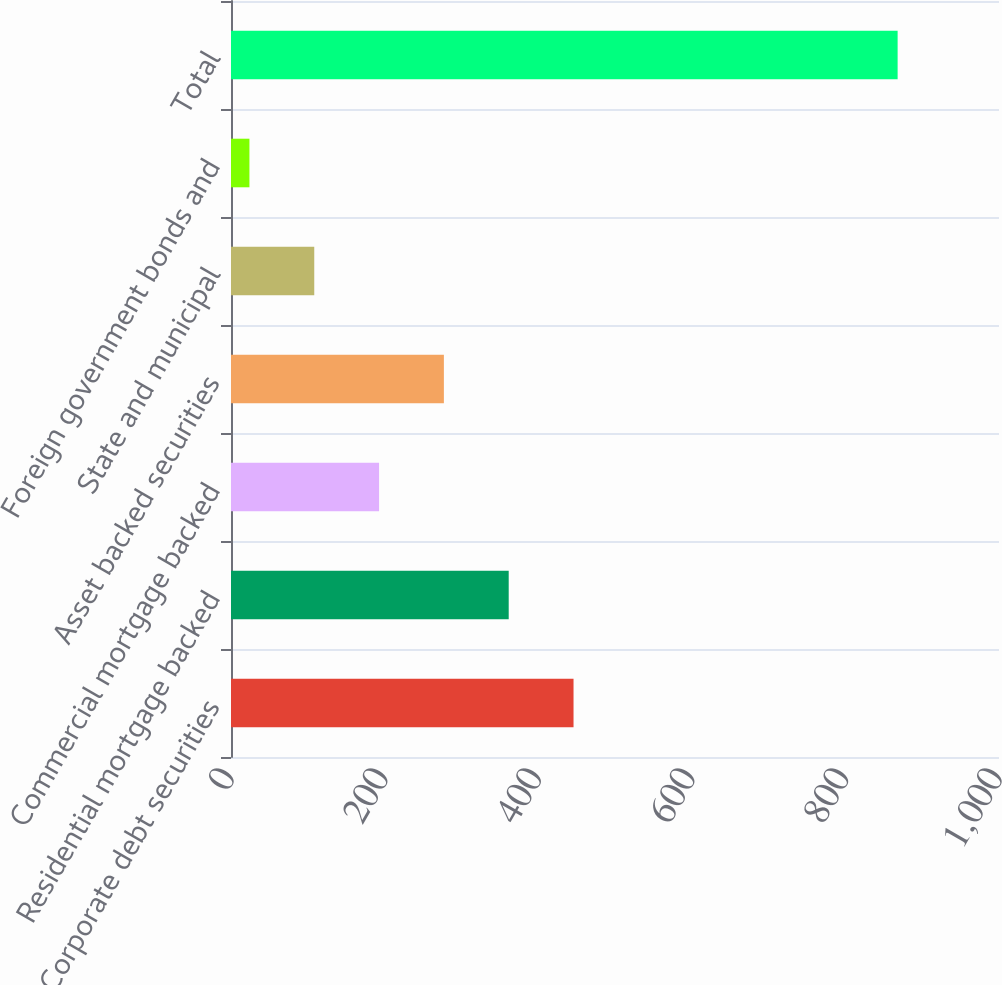<chart> <loc_0><loc_0><loc_500><loc_500><bar_chart><fcel>Corporate debt securities<fcel>Residential mortgage backed<fcel>Commercial mortgage backed<fcel>Asset backed securities<fcel>State and municipal<fcel>Foreign government bonds and<fcel>Total<nl><fcel>446<fcel>361.6<fcel>192.8<fcel>277.2<fcel>108.4<fcel>24<fcel>868<nl></chart> 